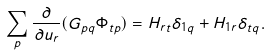Convert formula to latex. <formula><loc_0><loc_0><loc_500><loc_500>\sum _ { p } \frac { \partial } { \partial u _ { r } } ( G _ { p q } \Phi _ { t p } ) = H _ { r t } \delta _ { 1 q } + H _ { 1 r } \delta _ { t q } .</formula> 